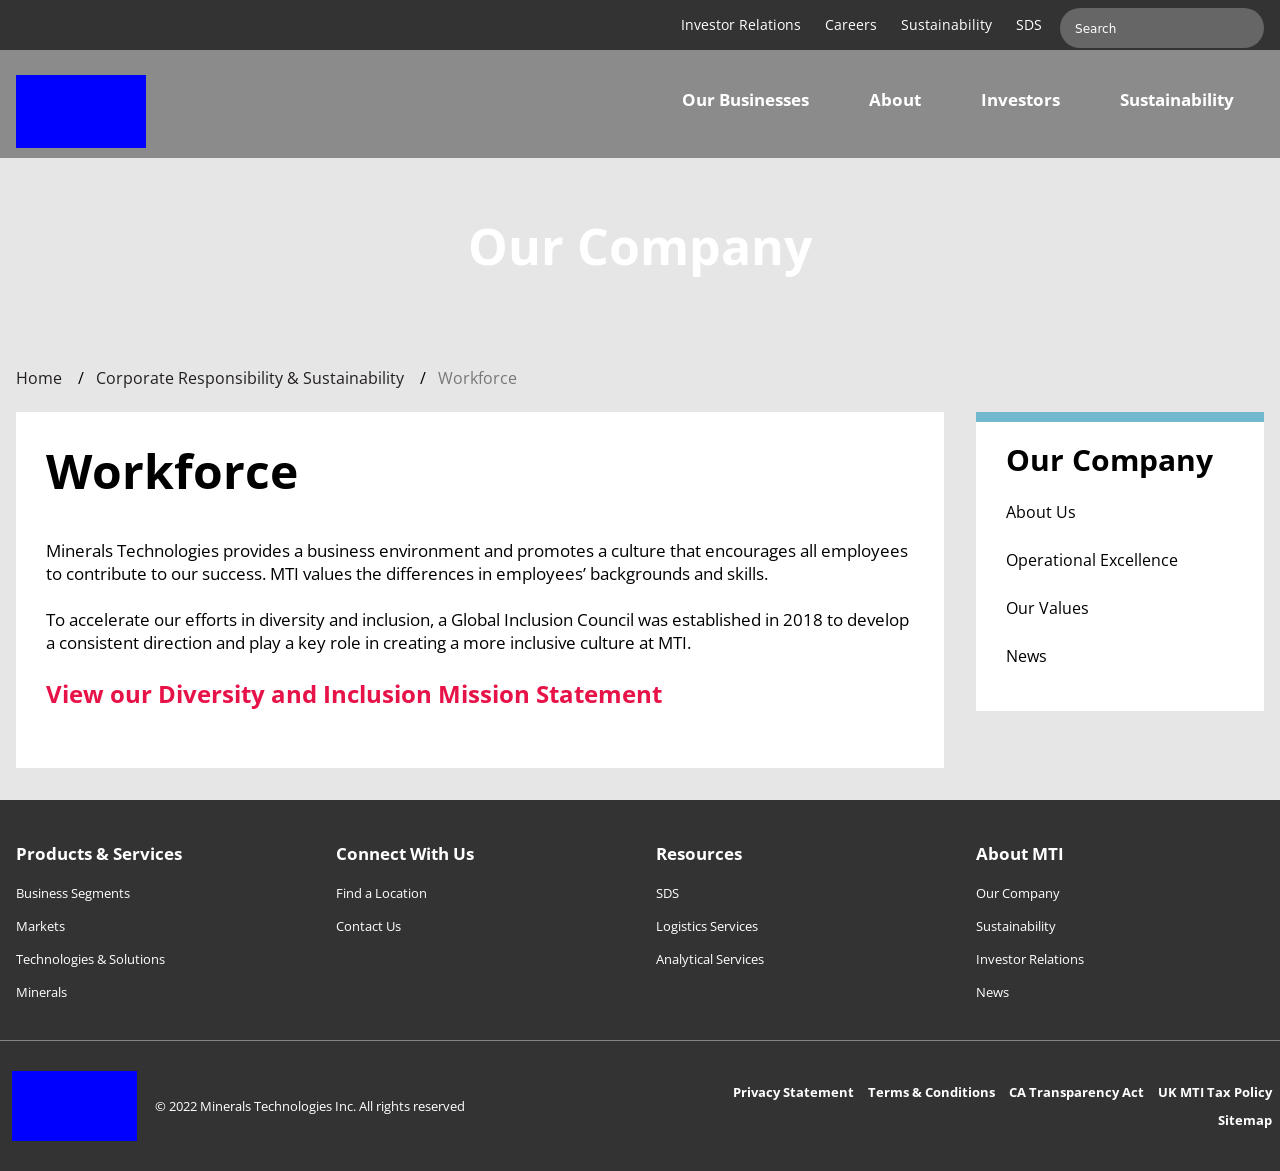Could you describe the purpose and content of the 'Workforce' section shown in the website image? The 'Workforce' section of the website focuses on highlighting the company's dedication towards creating an encouraging and diverse working environment. It mentions the company's efforts via a Global Inclusion Council and their initiative to create a more inclusive culture. It also includes an invitation to view their Diversity and Inclusion Mission Statement. 